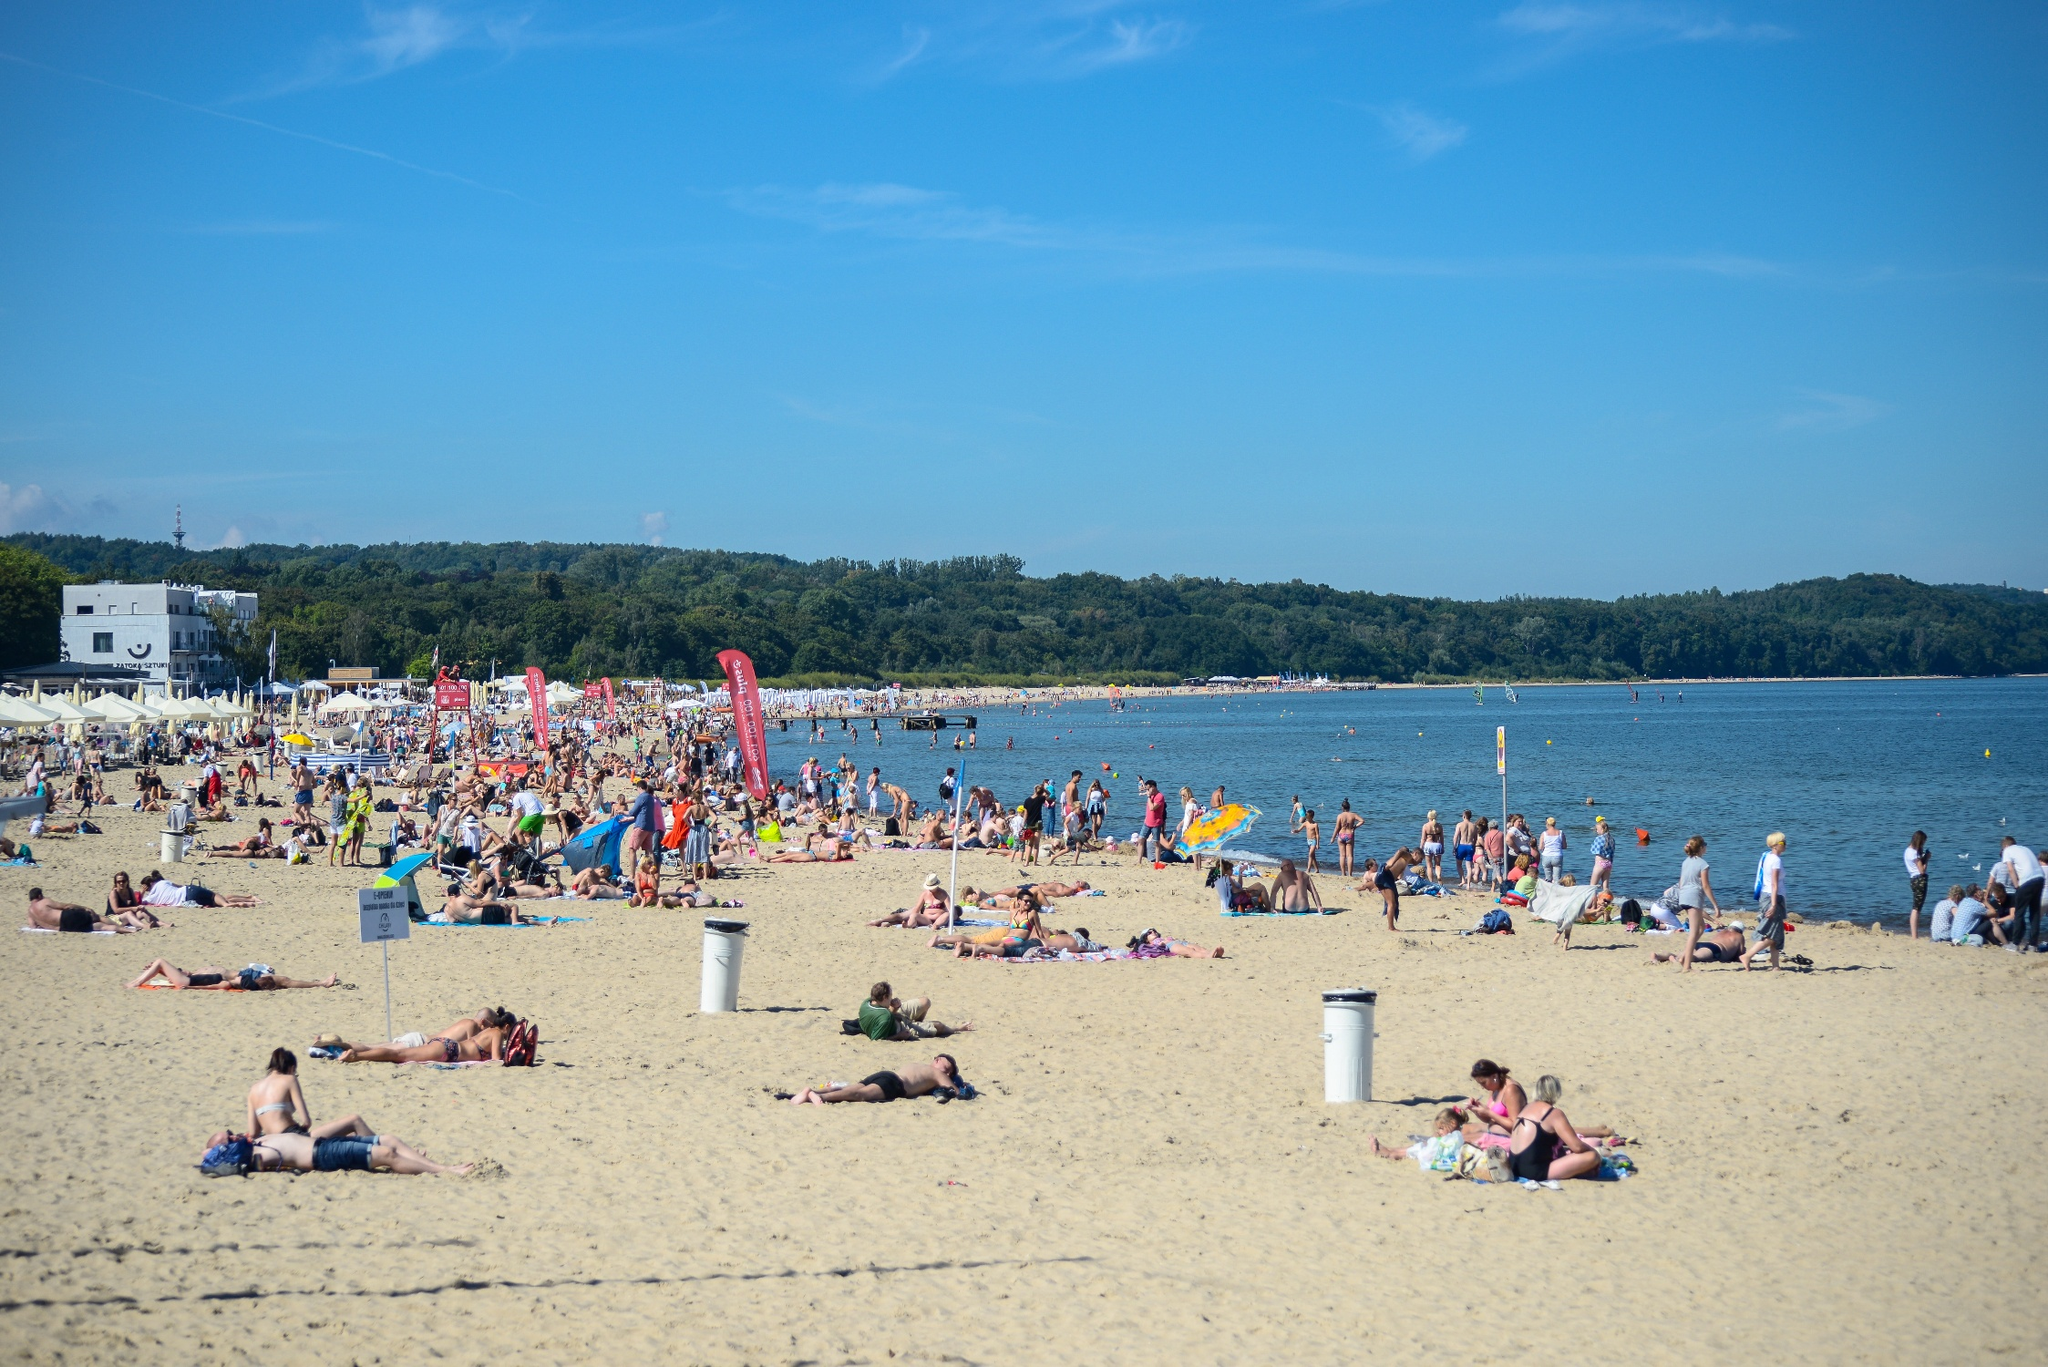What do you see happening in this image?
 The image captures a lively beach scene, bustling with people enjoying the sun and sand. The beach, with its light beige sand, stretches out to meet the body of water on the right, while a white building stands on the left, adding a touch of urbanity to the natural landscape. The sky above is a clear blue, creating a beautiful contrast with the earthy tones of the beach below.

People are scattered across the beach, some sunbathing, others walking around, creating a sense of movement and activity. Flags and banners add splashes of color to the scene, while trash cans and umbrellas dot the landscape, indicating the amenities available for beachgoers. 

The perspective of the image is from a distance, looking down on the beach from above, providing a comprehensive view of the entire scene. This bird's-eye view allows for a full appreciation of the beach's layout and the activities taking place. Despite the distance, the image is detailed enough to convey the vibrant atmosphere of the beach. 

As for the landmark information "sa_1669", I wasn't able to find specific details related to this code in my current knowledge. It might be helpful to provide more context or details about the landmark for a more accurate identification. 